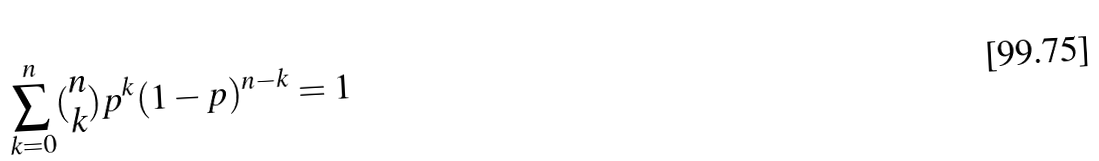<formula> <loc_0><loc_0><loc_500><loc_500>\sum _ { k = 0 } ^ { n } ( \begin{matrix} n \\ k \end{matrix} ) p ^ { k } ( 1 - p ) ^ { n - k } = 1</formula> 